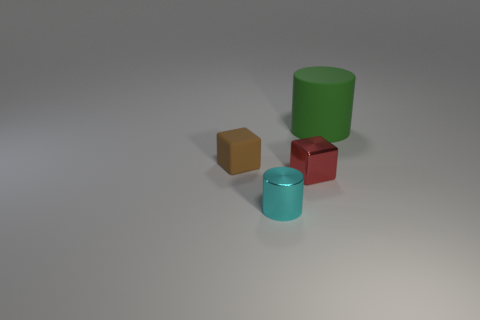How many other objects are the same material as the brown block?
Give a very brief answer. 1. There is a matte thing in front of the big rubber cylinder; is its shape the same as the tiny metal thing on the left side of the red shiny block?
Make the answer very short. No. There is a tiny cube left of the cylinder to the left of the small cube that is on the right side of the brown rubber object; what color is it?
Provide a short and direct response. Brown. What number of other objects are the same color as the big thing?
Make the answer very short. 0. Are there fewer matte cylinders than big green shiny balls?
Offer a very short reply. No. There is a tiny thing that is both behind the small cylinder and right of the small brown cube; what is its color?
Provide a short and direct response. Red. There is a large green thing that is the same shape as the cyan object; what is it made of?
Keep it short and to the point. Rubber. Is there anything else that has the same size as the green cylinder?
Give a very brief answer. No. Are there more big green rubber cylinders than tiny yellow rubber cubes?
Offer a very short reply. Yes. What is the size of the thing that is to the left of the tiny red cube and right of the small brown rubber thing?
Offer a very short reply. Small. 